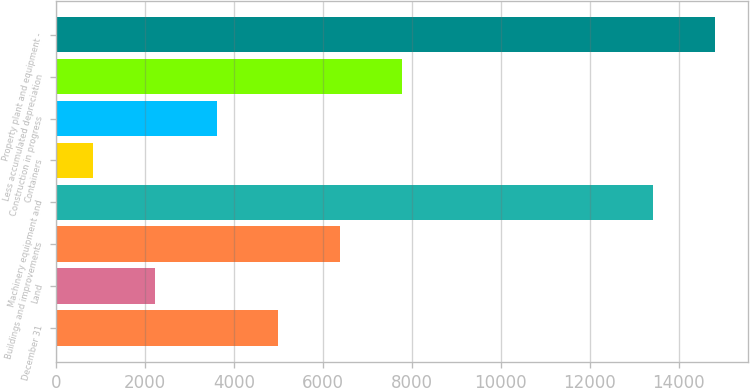<chart> <loc_0><loc_0><loc_500><loc_500><bar_chart><fcel>December 31<fcel>Land<fcel>Buildings and improvements<fcel>Machinery equipment and<fcel>Containers<fcel>Construction in progress<fcel>Less accumulated depreciation<fcel>Property plant and equipment -<nl><fcel>4996.3<fcel>2216.1<fcel>6386.4<fcel>13421<fcel>826<fcel>3606.2<fcel>7776.5<fcel>14811.1<nl></chart> 